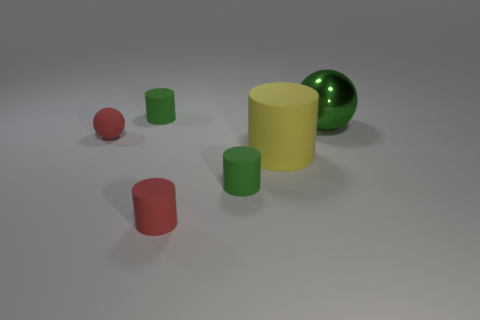What is the color of the large cylinder in front of the tiny red matte sphere?
Your answer should be compact. Yellow. Is the shape of the yellow thing the same as the large object behind the yellow thing?
Keep it short and to the point. No. Is there a large thing that has the same color as the rubber ball?
Give a very brief answer. No. The yellow thing that is made of the same material as the red cylinder is what size?
Your response must be concise. Large. Do the big metal sphere and the big cylinder have the same color?
Keep it short and to the point. No. There is a small red object that is in front of the tiny rubber sphere; does it have the same shape as the large green shiny object?
Make the answer very short. No. What number of balls have the same size as the red cylinder?
Keep it short and to the point. 1. There is a tiny object that is the same color as the small matte sphere; what shape is it?
Ensure brevity in your answer.  Cylinder. There is a green cylinder that is to the left of the small red rubber cylinder; are there any small green rubber cylinders that are in front of it?
Ensure brevity in your answer.  Yes. How many things are either small green rubber cylinders in front of the large green thing or large gray rubber spheres?
Ensure brevity in your answer.  1. 